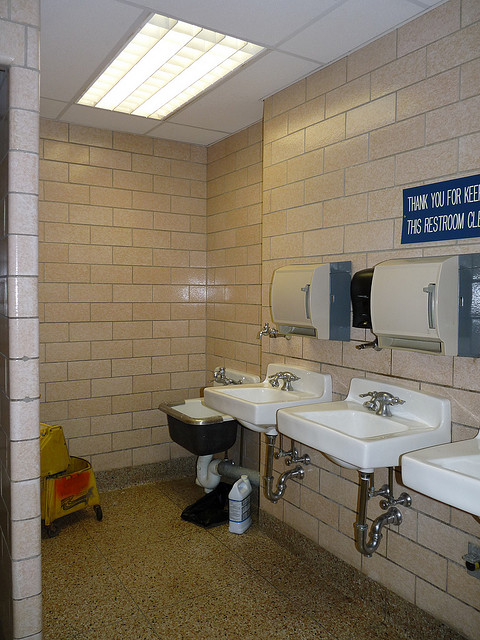Are the sinks equipped with hot water? Based on the image which shows a commercial restroom setup, it is likely that the sinks are equipped with both hot and cold water to accommodate basic hygiene needs. 